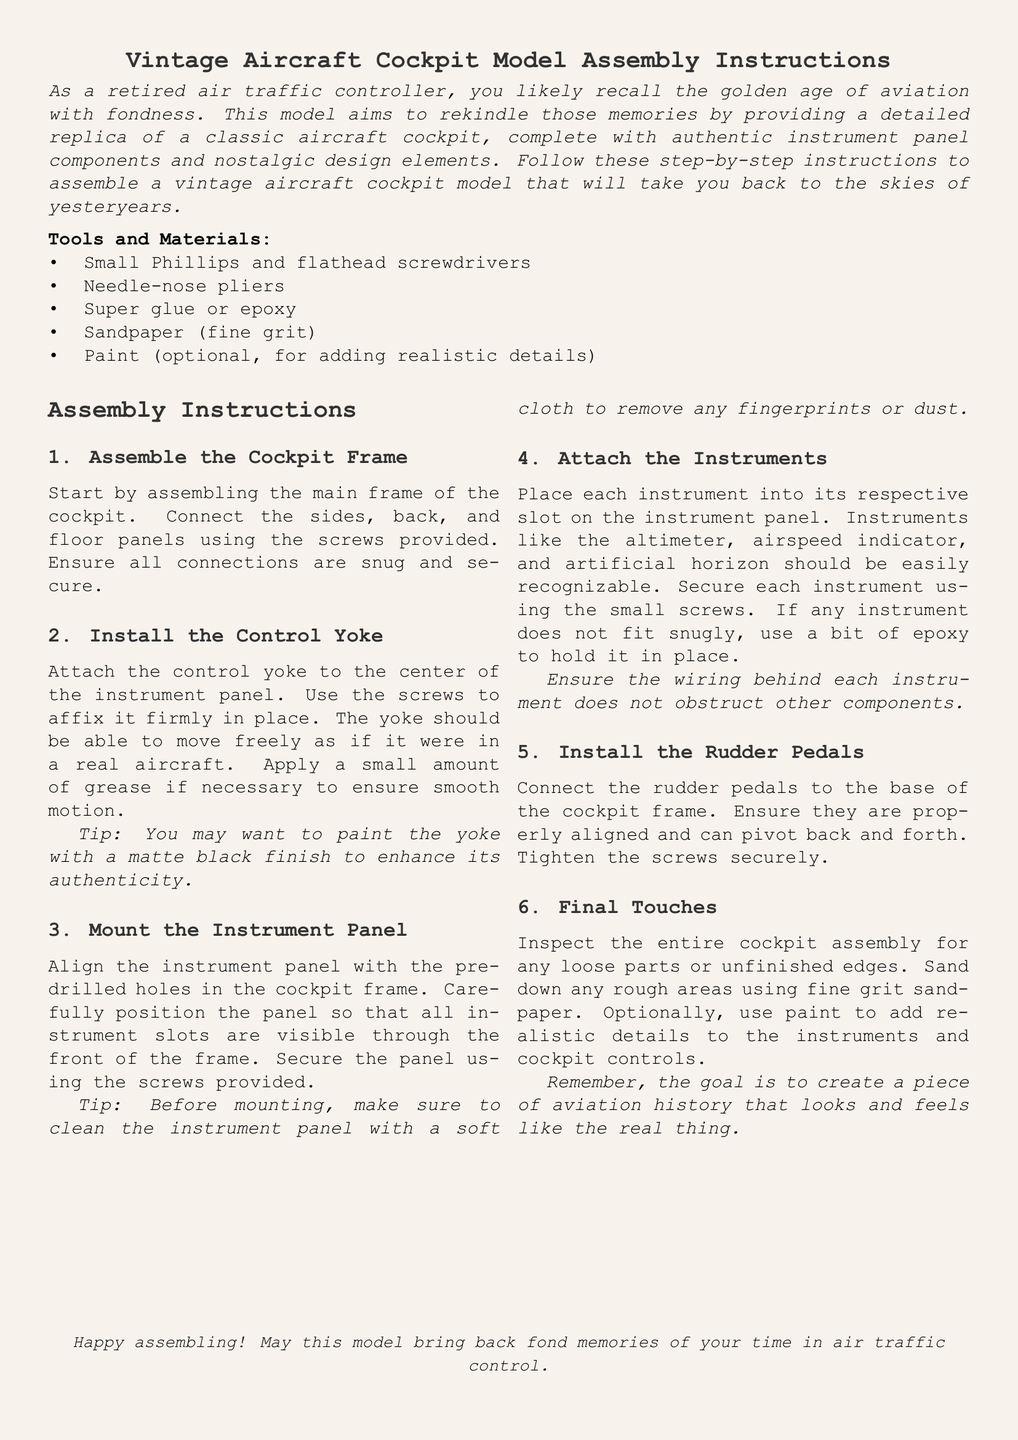What is the document's title? The title is presented prominently at the beginning of the document in a larger font.
Answer: Vintage Aircraft Cockpit Model Assembly Instructions What tools are needed for assembly? The tools are listed in a dedicated section in the document to ensure clarity.
Answer: Small Phillips and flathead screwdrivers, needle-nose pliers, super glue or epoxy, sandpaper, paint How many assembly instructions are listed? The document specifies the number of distinct tasks in the assembly process.
Answer: Six What component is attached to the center of the instrument panel? This detail is important for understanding the layout of the cockpit model.
Answer: Control yoke What should be used to secure the instruments in place? This is essential information on how to assemble the instrument panel correctly.
Answer: Small screws or epoxy What color is suggested for the control yoke? The document gives a suggestion for enhancing the realism of the model.
Answer: Matte black What is the final step in the assembly process? The conclusion of the assembly instructions provides insight into the finishing touches.
Answer: Final Touches Why should the instrument panel be cleaned before mounting? This detail emphasizes the importance of presentation in the assembly process.
Answer: To remove any fingerprints or dust What does the document aim to rekindle through its model? The purpose of this assembly is foundational to its nostalgic intent.
Answer: Fond memories of aviation 